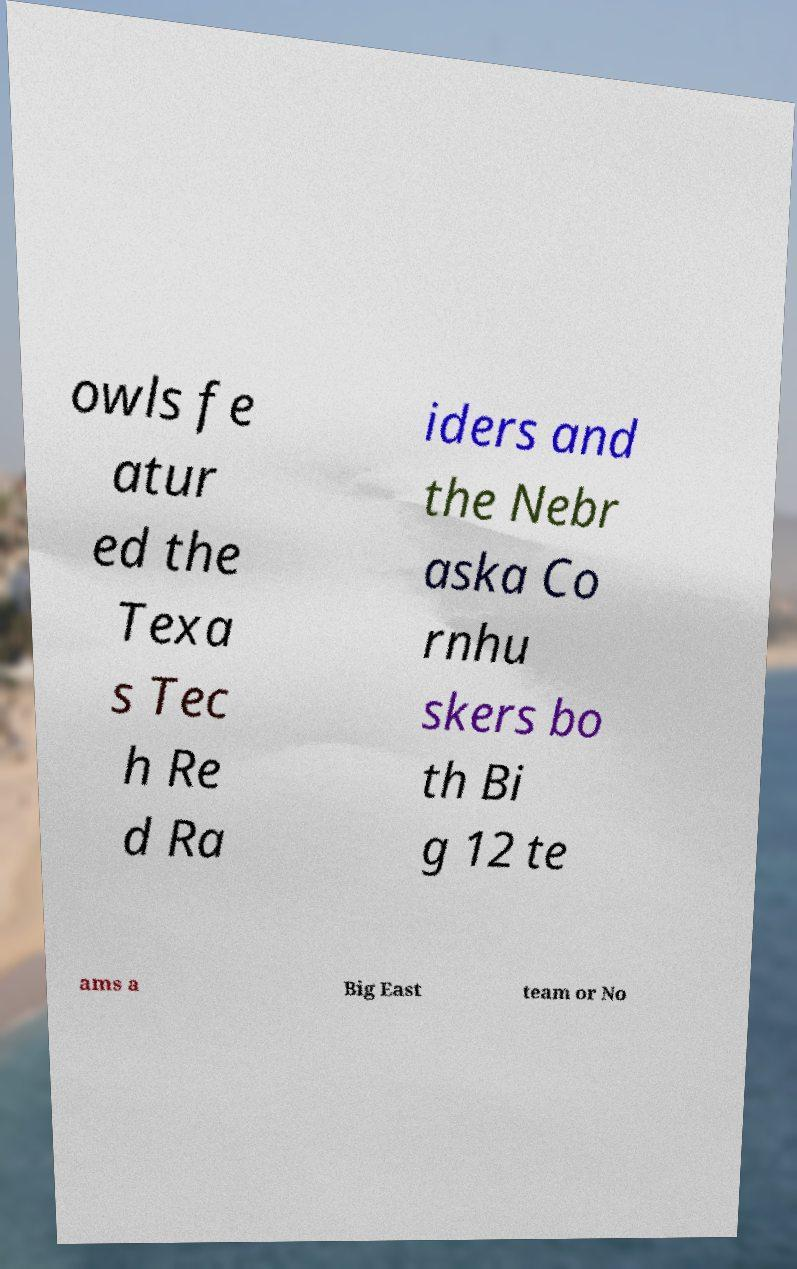Please identify and transcribe the text found in this image. owls fe atur ed the Texa s Tec h Re d Ra iders and the Nebr aska Co rnhu skers bo th Bi g 12 te ams a Big East team or No 